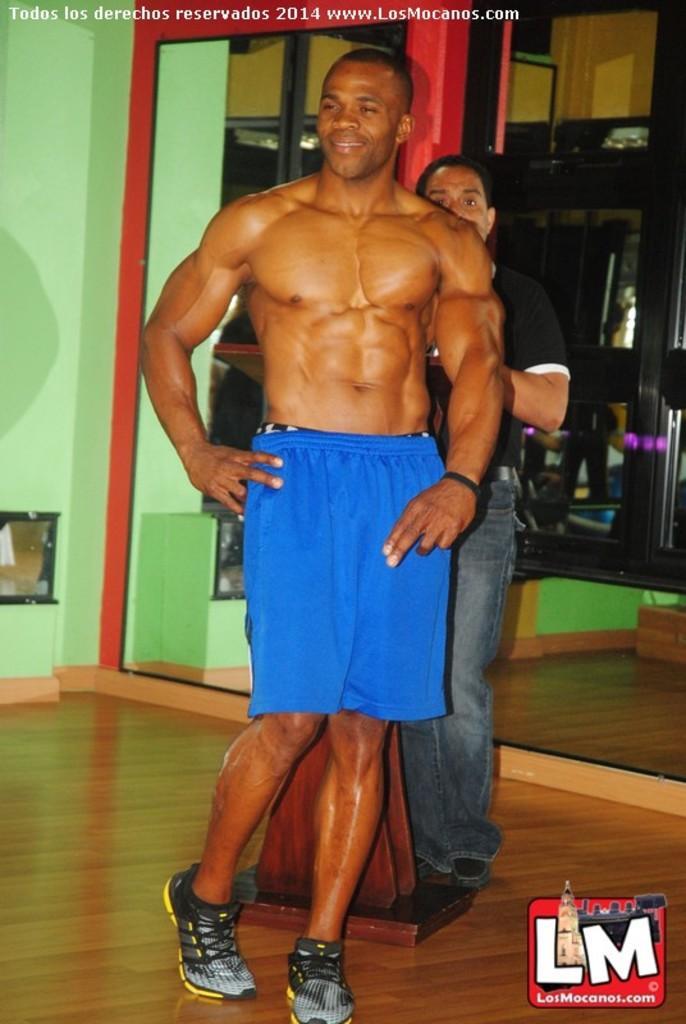Please provide a concise description of this image. In this picture there is a bodybuilder who is wearing short and shoes. Behind him there is a man who is wearing t-shirt, jeans and shoes. He is standing near to the door. Through the door I can see the cupboards and shelves. In the bottom right corner there is a watermark. On the left there is a box on the green wall. 